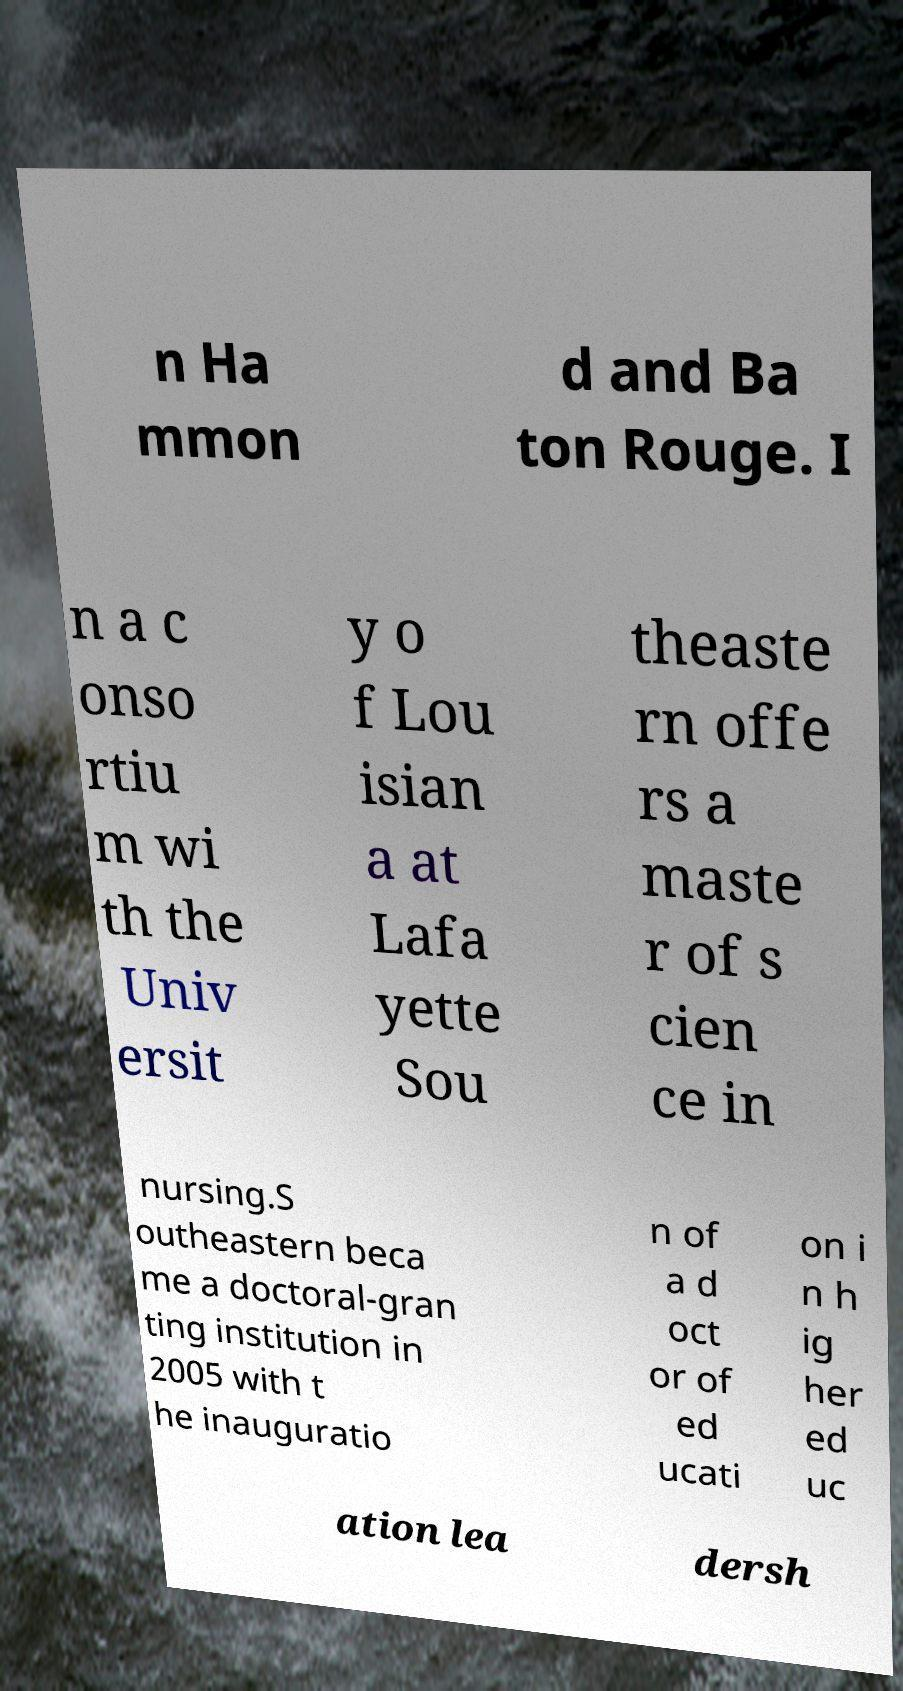Can you read and provide the text displayed in the image?This photo seems to have some interesting text. Can you extract and type it out for me? n Ha mmon d and Ba ton Rouge. I n a c onso rtiu m wi th the Univ ersit y o f Lou isian a at Lafa yette Sou theaste rn offe rs a maste r of s cien ce in nursing.S outheastern beca me a doctoral-gran ting institution in 2005 with t he inauguratio n of a d oct or of ed ucati on i n h ig her ed uc ation lea dersh 